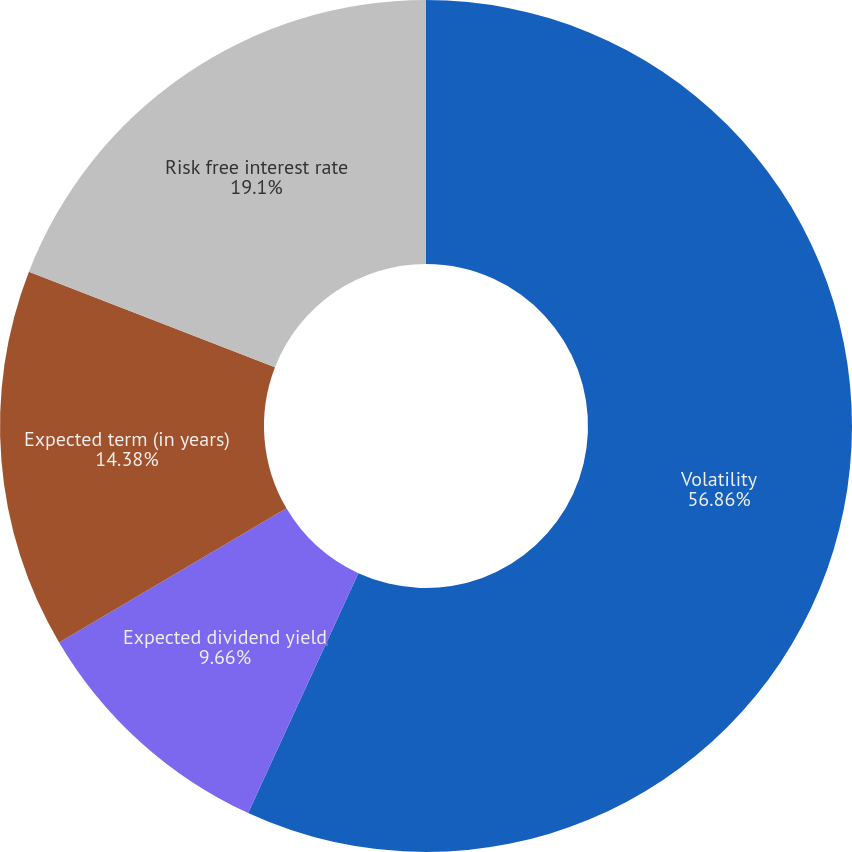Convert chart. <chart><loc_0><loc_0><loc_500><loc_500><pie_chart><fcel>Volatility<fcel>Expected dividend yield<fcel>Expected term (in years)<fcel>Risk free interest rate<nl><fcel>56.85%<fcel>9.66%<fcel>14.38%<fcel>19.1%<nl></chart> 